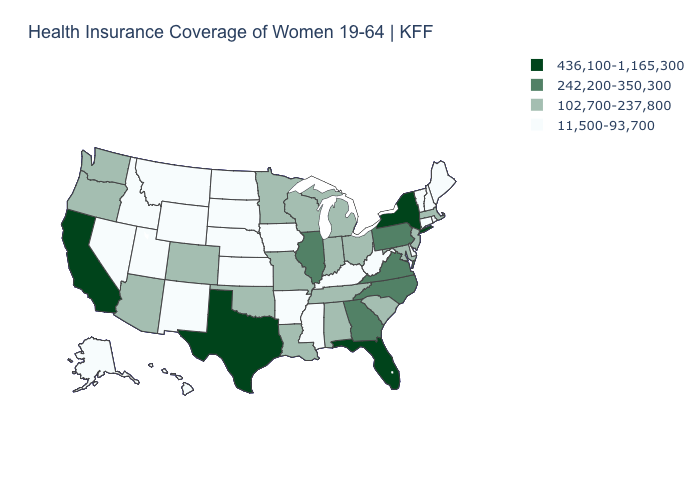Is the legend a continuous bar?
Answer briefly. No. Among the states that border Maine , which have the lowest value?
Short answer required. New Hampshire. What is the value of Oklahoma?
Give a very brief answer. 102,700-237,800. Does Ohio have the same value as New York?
Write a very short answer. No. Name the states that have a value in the range 242,200-350,300?
Short answer required. Georgia, Illinois, North Carolina, Pennsylvania, Virginia. How many symbols are there in the legend?
Keep it brief. 4. Does Nebraska have the lowest value in the MidWest?
Give a very brief answer. Yes. Does Maryland have a higher value than Idaho?
Write a very short answer. Yes. How many symbols are there in the legend?
Keep it brief. 4. Which states hav the highest value in the MidWest?
Short answer required. Illinois. Name the states that have a value in the range 436,100-1,165,300?
Be succinct. California, Florida, New York, Texas. Does Kentucky have the lowest value in the USA?
Answer briefly. Yes. Among the states that border Louisiana , which have the lowest value?
Write a very short answer. Arkansas, Mississippi. What is the value of New Hampshire?
Write a very short answer. 11,500-93,700. Name the states that have a value in the range 436,100-1,165,300?
Short answer required. California, Florida, New York, Texas. 